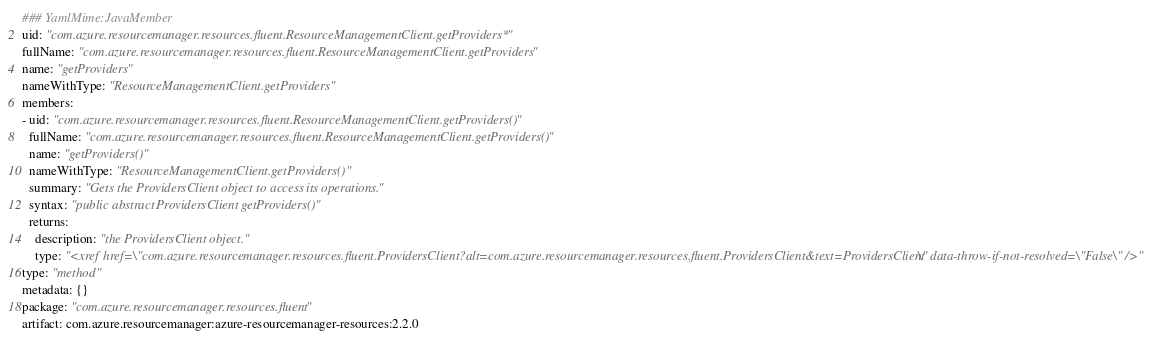Convert code to text. <code><loc_0><loc_0><loc_500><loc_500><_YAML_>### YamlMime:JavaMember
uid: "com.azure.resourcemanager.resources.fluent.ResourceManagementClient.getProviders*"
fullName: "com.azure.resourcemanager.resources.fluent.ResourceManagementClient.getProviders"
name: "getProviders"
nameWithType: "ResourceManagementClient.getProviders"
members:
- uid: "com.azure.resourcemanager.resources.fluent.ResourceManagementClient.getProviders()"
  fullName: "com.azure.resourcemanager.resources.fluent.ResourceManagementClient.getProviders()"
  name: "getProviders()"
  nameWithType: "ResourceManagementClient.getProviders()"
  summary: "Gets the ProvidersClient object to access its operations."
  syntax: "public abstract ProvidersClient getProviders()"
  returns:
    description: "the ProvidersClient object."
    type: "<xref href=\"com.azure.resourcemanager.resources.fluent.ProvidersClient?alt=com.azure.resourcemanager.resources.fluent.ProvidersClient&text=ProvidersClient\" data-throw-if-not-resolved=\"False\" />"
type: "method"
metadata: {}
package: "com.azure.resourcemanager.resources.fluent"
artifact: com.azure.resourcemanager:azure-resourcemanager-resources:2.2.0
</code> 